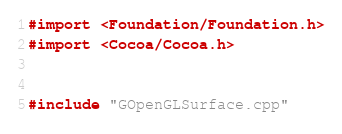Convert code to text. <code><loc_0><loc_0><loc_500><loc_500><_ObjectiveC_>#import <Foundation/Foundation.h>
#import <Cocoa/Cocoa.h>


#include "GOpenGLSurface.cpp"
</code> 